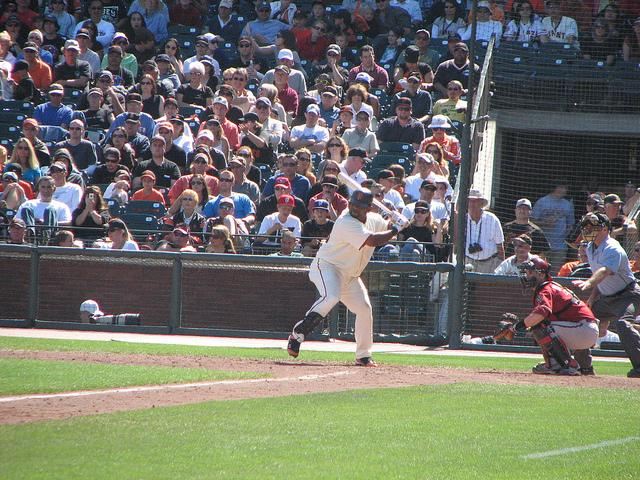What is different about this batter from most batters? Please explain your reasoning. left-handed batter. By his position on the batters box you can tell he is left handed. 